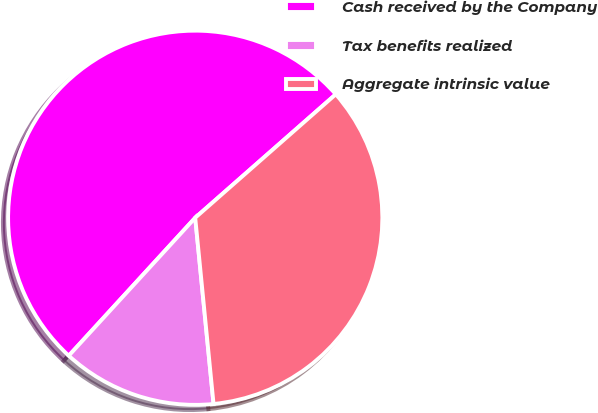Convert chart. <chart><loc_0><loc_0><loc_500><loc_500><pie_chart><fcel>Cash received by the Company<fcel>Tax benefits realized<fcel>Aggregate intrinsic value<nl><fcel>51.72%<fcel>13.37%<fcel>34.91%<nl></chart> 